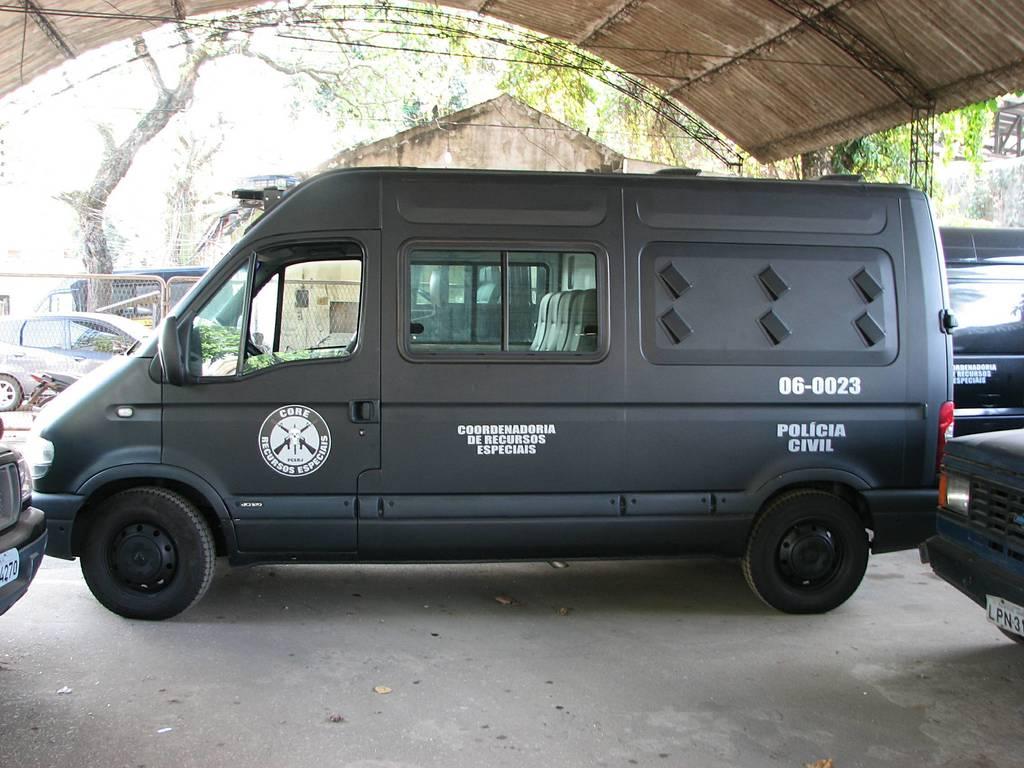What is written on this van?
Offer a very short reply. Policia civil. What numbers are on the side?
Provide a short and direct response. 06-0023. 